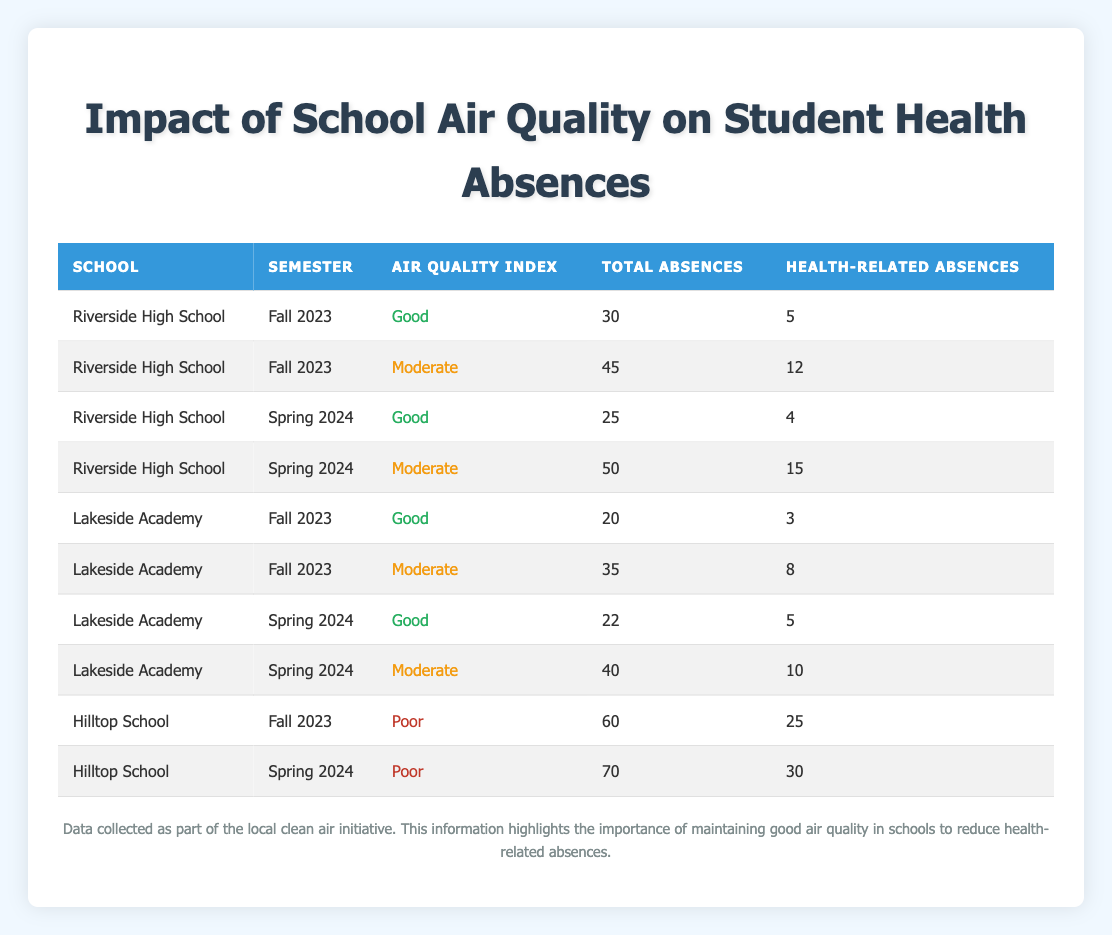What is the total number of health-related absences at Riverside High School in Fall 2023? From the table, we can see that for Riverside High School in Fall 2023, the health-related absences are listed as 5 for the Good air quality and 12 for the Moderate air quality. To get the total, we sum these two values: 5 + 12 = 17.
Answer: 17 What was the air quality index for Lakeside Academy in Spring 2024? For Lakeside Academy in Spring 2024, the air quality index is listed as Good for one row and Moderate for another row. The question asks specifically for the air quality index, which is mentioned clearly in the rows for that school and semester.
Answer: Good and Moderate Which semester had the highest total absences across all schools? Looking through the table, we can see the total absences for each school and semester. In Fall 2023, Riverside High School had 45 and Hilltop School had 60, making a total of 105. In Spring 2024, Riverside High School had 50 and Hilltop School had 70, adding up to 120. The highest total absences are thus 120 in Spring 2024.
Answer: Spring 2024 Is there a relationship between air quality index and health-related absences? To assess the relationship, we look at the data: Poor air quality at Hilltop School in Fall 2023 had 25 health-related absences out of 60 total. In contrast, Riverside High School with Good air quality had only 5 health-related absences out of 30 total. This suggests that poorer air quality correlates with a higher rate of health-related absences.
Answer: Yes What is the average number of health-related absences in Fall 2023 for schools with moderate air quality? The moderate air quality rows in Fall 2023 are 12 (Riverside High School) and 8 (Lakeside Academy). We calculate the average by summing these values (12 + 8 = 20) and dividing by the number of schools (2). The average is 20 / 2 = 10.
Answer: 10 How many total absences did Hilltop School have in Spring 2024? For Hilltop School in Spring 2024, the data row indicates that the total absences are 70. Therefore, the total number of absences for this school and semester is directly stated in the table.
Answer: 70 Did Lakeside Academy have more health-related absences in Fall or Spring 2024? We compare the health-related absences for Lakeside Academy in the two semesters: in Fall 2023, they had 8 (Moderate air quality), while in Spring 2024, they had 5 (Good air quality). We can see that Fall 2023 had more absences than Spring 2024.
Answer: Fall 2023 What is the difference in total absences between Riverside High School and Lakeside Academy in Fall 2023? Riverside High School had 45 total absences (Moderate air quality) and Lakeside Academy had 35 total absences (Moderate air quality) in Fall 2023. To find the difference, we subtract the total absences of Lakeside Academy from Riverside High School: 45 - 35 = 10.
Answer: 10 How many health-related absences were recorded at all schools for the Spring 2024 semester? To find the total health-related absences for Spring 2024, we sum the values for all schools: Riverside High School had 4 (Good) + 15 (Moderate), Lakeside Academy had 5 (Good) + 10 (Moderate), and Hilltop School had 30 (Poor). The total is 4 + 15 + 5 + 10 + 30 = 64.
Answer: 64 